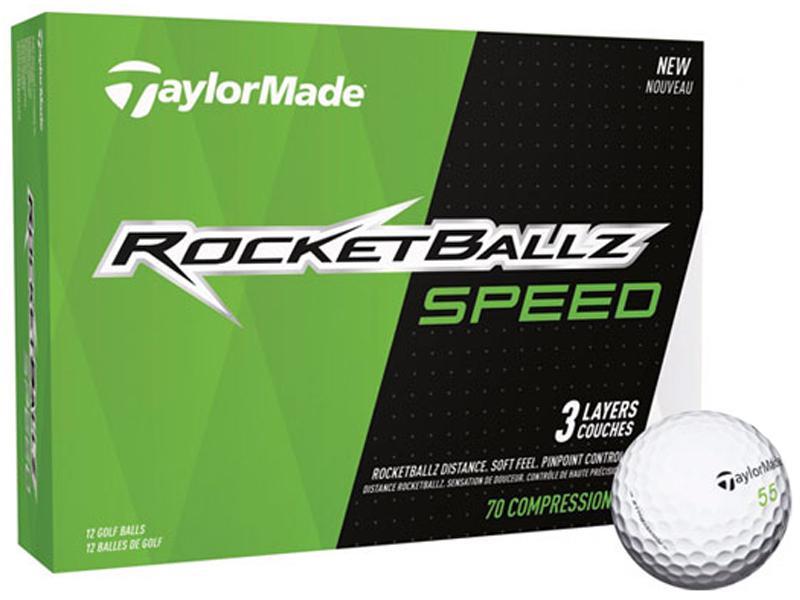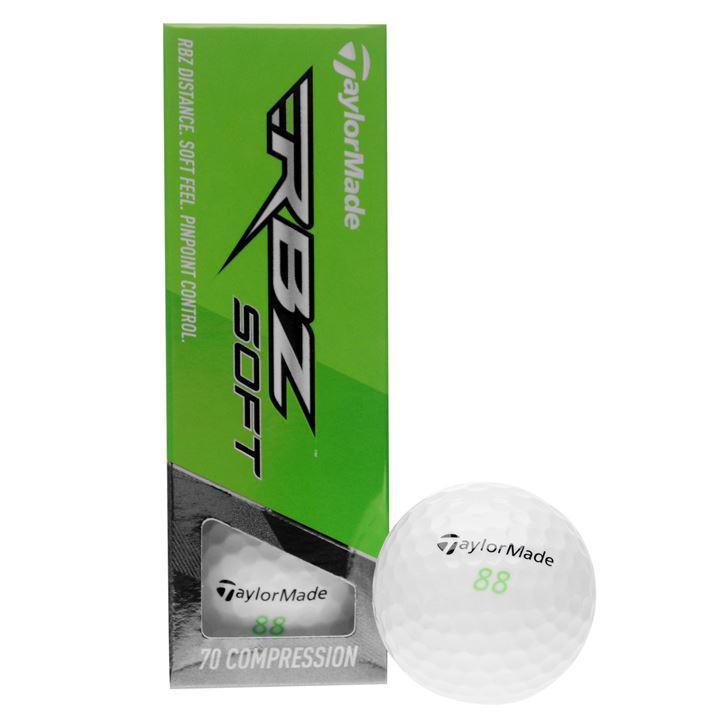The first image is the image on the left, the second image is the image on the right. Considering the images on both sides, is "The left image shows a box with """"RBZ SOFT"""" shown on it." valid? Answer yes or no. No. 